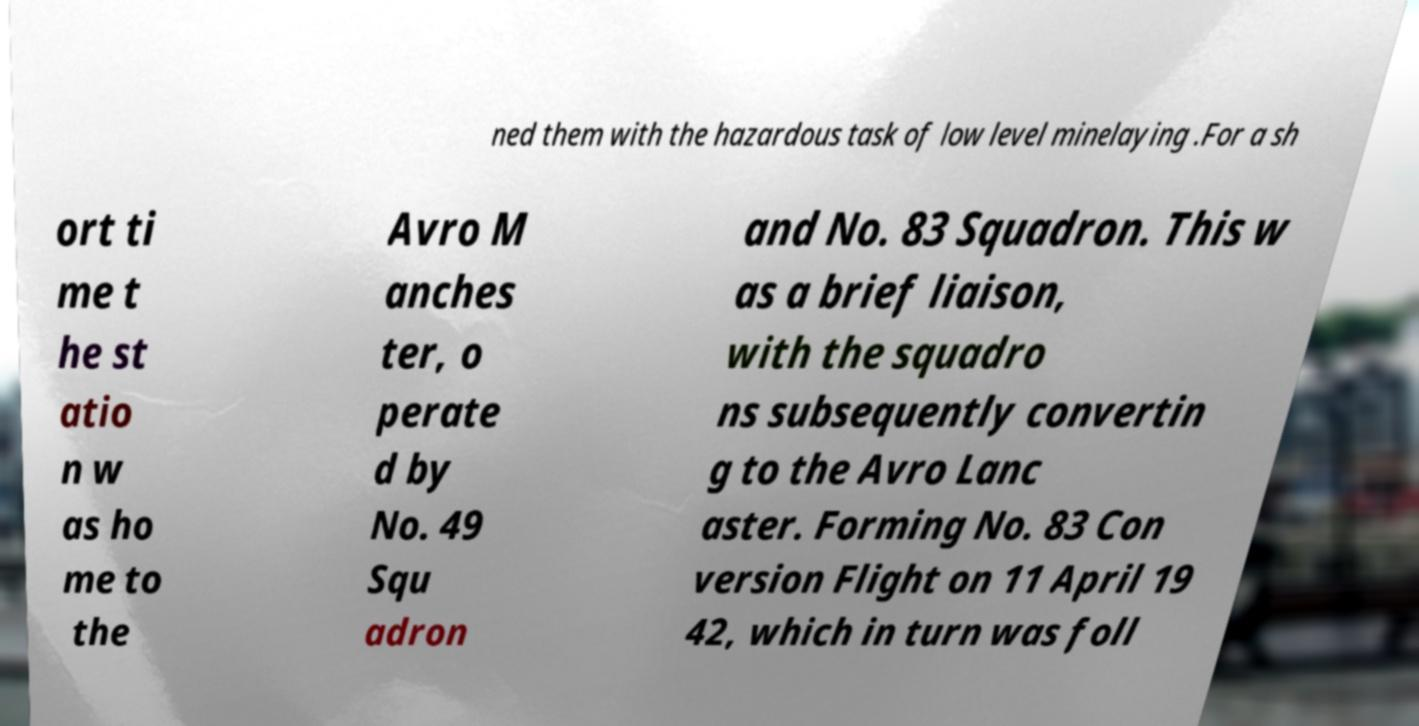For documentation purposes, I need the text within this image transcribed. Could you provide that? ned them with the hazardous task of low level minelaying .For a sh ort ti me t he st atio n w as ho me to the Avro M anches ter, o perate d by No. 49 Squ adron and No. 83 Squadron. This w as a brief liaison, with the squadro ns subsequently convertin g to the Avro Lanc aster. Forming No. 83 Con version Flight on 11 April 19 42, which in turn was foll 